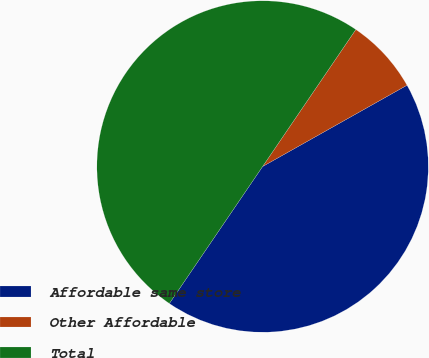Convert chart to OTSL. <chart><loc_0><loc_0><loc_500><loc_500><pie_chart><fcel>Affordable same store<fcel>Other Affordable<fcel>Total<nl><fcel>42.67%<fcel>7.33%<fcel>50.0%<nl></chart> 